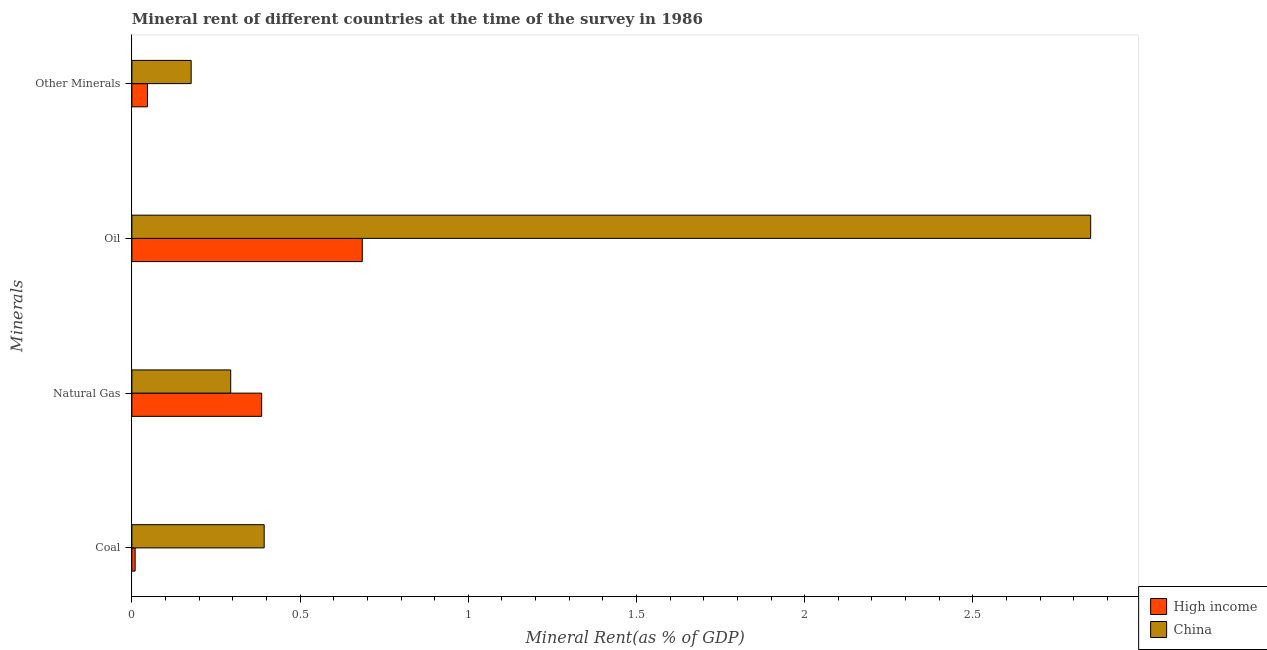Are the number of bars on each tick of the Y-axis equal?
Ensure brevity in your answer.  Yes. How many bars are there on the 2nd tick from the top?
Your answer should be very brief. 2. What is the label of the 4th group of bars from the top?
Your answer should be compact. Coal. What is the oil rent in High income?
Offer a terse response. 0.68. Across all countries, what is the maximum  rent of other minerals?
Your answer should be very brief. 0.18. Across all countries, what is the minimum natural gas rent?
Your response must be concise. 0.29. In which country was the natural gas rent minimum?
Provide a succinct answer. China. What is the total  rent of other minerals in the graph?
Your answer should be very brief. 0.22. What is the difference between the natural gas rent in High income and that in China?
Ensure brevity in your answer.  0.09. What is the difference between the oil rent in High income and the  rent of other minerals in China?
Offer a very short reply. 0.51. What is the average natural gas rent per country?
Your response must be concise. 0.34. What is the difference between the  rent of other minerals and oil rent in China?
Make the answer very short. -2.67. In how many countries, is the oil rent greater than 0.2 %?
Provide a succinct answer. 2. What is the ratio of the oil rent in China to that in High income?
Provide a succinct answer. 4.16. What is the difference between the highest and the second highest  rent of other minerals?
Offer a terse response. 0.13. What is the difference between the highest and the lowest  rent of other minerals?
Your response must be concise. 0.13. Is it the case that in every country, the sum of the natural gas rent and  rent of other minerals is greater than the sum of oil rent and coal rent?
Keep it short and to the point. Yes. How many bars are there?
Offer a terse response. 8. Does the graph contain any zero values?
Provide a succinct answer. No. Where does the legend appear in the graph?
Offer a very short reply. Bottom right. How are the legend labels stacked?
Ensure brevity in your answer.  Vertical. What is the title of the graph?
Give a very brief answer. Mineral rent of different countries at the time of the survey in 1986. Does "Marshall Islands" appear as one of the legend labels in the graph?
Give a very brief answer. No. What is the label or title of the X-axis?
Provide a succinct answer. Mineral Rent(as % of GDP). What is the label or title of the Y-axis?
Your answer should be very brief. Minerals. What is the Mineral Rent(as % of GDP) in High income in Coal?
Keep it short and to the point. 0.01. What is the Mineral Rent(as % of GDP) of China in Coal?
Your answer should be compact. 0.39. What is the Mineral Rent(as % of GDP) in High income in Natural Gas?
Ensure brevity in your answer.  0.39. What is the Mineral Rent(as % of GDP) in China in Natural Gas?
Your answer should be very brief. 0.29. What is the Mineral Rent(as % of GDP) of High income in Oil?
Keep it short and to the point. 0.68. What is the Mineral Rent(as % of GDP) in China in Oil?
Provide a succinct answer. 2.85. What is the Mineral Rent(as % of GDP) in High income in Other Minerals?
Give a very brief answer. 0.05. What is the Mineral Rent(as % of GDP) of China in Other Minerals?
Your response must be concise. 0.18. Across all Minerals, what is the maximum Mineral Rent(as % of GDP) of High income?
Give a very brief answer. 0.68. Across all Minerals, what is the maximum Mineral Rent(as % of GDP) of China?
Your answer should be very brief. 2.85. Across all Minerals, what is the minimum Mineral Rent(as % of GDP) of High income?
Your answer should be compact. 0.01. Across all Minerals, what is the minimum Mineral Rent(as % of GDP) in China?
Offer a terse response. 0.18. What is the total Mineral Rent(as % of GDP) in High income in the graph?
Offer a very short reply. 1.13. What is the total Mineral Rent(as % of GDP) of China in the graph?
Offer a terse response. 3.71. What is the difference between the Mineral Rent(as % of GDP) in High income in Coal and that in Natural Gas?
Provide a succinct answer. -0.38. What is the difference between the Mineral Rent(as % of GDP) in China in Coal and that in Natural Gas?
Keep it short and to the point. 0.1. What is the difference between the Mineral Rent(as % of GDP) in High income in Coal and that in Oil?
Your answer should be very brief. -0.68. What is the difference between the Mineral Rent(as % of GDP) in China in Coal and that in Oil?
Offer a very short reply. -2.46. What is the difference between the Mineral Rent(as % of GDP) in High income in Coal and that in Other Minerals?
Offer a very short reply. -0.04. What is the difference between the Mineral Rent(as % of GDP) in China in Coal and that in Other Minerals?
Provide a short and direct response. 0.22. What is the difference between the Mineral Rent(as % of GDP) of High income in Natural Gas and that in Oil?
Make the answer very short. -0.3. What is the difference between the Mineral Rent(as % of GDP) of China in Natural Gas and that in Oil?
Offer a very short reply. -2.56. What is the difference between the Mineral Rent(as % of GDP) of High income in Natural Gas and that in Other Minerals?
Your response must be concise. 0.34. What is the difference between the Mineral Rent(as % of GDP) of China in Natural Gas and that in Other Minerals?
Offer a terse response. 0.12. What is the difference between the Mineral Rent(as % of GDP) of High income in Oil and that in Other Minerals?
Offer a terse response. 0.64. What is the difference between the Mineral Rent(as % of GDP) of China in Oil and that in Other Minerals?
Keep it short and to the point. 2.67. What is the difference between the Mineral Rent(as % of GDP) in High income in Coal and the Mineral Rent(as % of GDP) in China in Natural Gas?
Ensure brevity in your answer.  -0.28. What is the difference between the Mineral Rent(as % of GDP) in High income in Coal and the Mineral Rent(as % of GDP) in China in Oil?
Keep it short and to the point. -2.84. What is the difference between the Mineral Rent(as % of GDP) of High income in Coal and the Mineral Rent(as % of GDP) of China in Other Minerals?
Keep it short and to the point. -0.17. What is the difference between the Mineral Rent(as % of GDP) in High income in Natural Gas and the Mineral Rent(as % of GDP) in China in Oil?
Keep it short and to the point. -2.46. What is the difference between the Mineral Rent(as % of GDP) of High income in Natural Gas and the Mineral Rent(as % of GDP) of China in Other Minerals?
Your answer should be compact. 0.21. What is the difference between the Mineral Rent(as % of GDP) of High income in Oil and the Mineral Rent(as % of GDP) of China in Other Minerals?
Ensure brevity in your answer.  0.51. What is the average Mineral Rent(as % of GDP) in High income per Minerals?
Offer a very short reply. 0.28. What is the average Mineral Rent(as % of GDP) in China per Minerals?
Offer a very short reply. 0.93. What is the difference between the Mineral Rent(as % of GDP) in High income and Mineral Rent(as % of GDP) in China in Coal?
Provide a succinct answer. -0.38. What is the difference between the Mineral Rent(as % of GDP) of High income and Mineral Rent(as % of GDP) of China in Natural Gas?
Give a very brief answer. 0.09. What is the difference between the Mineral Rent(as % of GDP) of High income and Mineral Rent(as % of GDP) of China in Oil?
Provide a short and direct response. -2.17. What is the difference between the Mineral Rent(as % of GDP) of High income and Mineral Rent(as % of GDP) of China in Other Minerals?
Your answer should be compact. -0.13. What is the ratio of the Mineral Rent(as % of GDP) of High income in Coal to that in Natural Gas?
Offer a terse response. 0.03. What is the ratio of the Mineral Rent(as % of GDP) in China in Coal to that in Natural Gas?
Your answer should be compact. 1.34. What is the ratio of the Mineral Rent(as % of GDP) of High income in Coal to that in Oil?
Provide a short and direct response. 0.01. What is the ratio of the Mineral Rent(as % of GDP) of China in Coal to that in Oil?
Offer a terse response. 0.14. What is the ratio of the Mineral Rent(as % of GDP) of High income in Coal to that in Other Minerals?
Provide a short and direct response. 0.21. What is the ratio of the Mineral Rent(as % of GDP) in China in Coal to that in Other Minerals?
Keep it short and to the point. 2.23. What is the ratio of the Mineral Rent(as % of GDP) of High income in Natural Gas to that in Oil?
Your answer should be compact. 0.56. What is the ratio of the Mineral Rent(as % of GDP) in China in Natural Gas to that in Oil?
Your answer should be very brief. 0.1. What is the ratio of the Mineral Rent(as % of GDP) of High income in Natural Gas to that in Other Minerals?
Provide a succinct answer. 8.33. What is the ratio of the Mineral Rent(as % of GDP) of China in Natural Gas to that in Other Minerals?
Your answer should be very brief. 1.67. What is the ratio of the Mineral Rent(as % of GDP) of High income in Oil to that in Other Minerals?
Keep it short and to the point. 14.79. What is the ratio of the Mineral Rent(as % of GDP) in China in Oil to that in Other Minerals?
Ensure brevity in your answer.  16.17. What is the difference between the highest and the second highest Mineral Rent(as % of GDP) of High income?
Ensure brevity in your answer.  0.3. What is the difference between the highest and the second highest Mineral Rent(as % of GDP) in China?
Give a very brief answer. 2.46. What is the difference between the highest and the lowest Mineral Rent(as % of GDP) of High income?
Your answer should be very brief. 0.68. What is the difference between the highest and the lowest Mineral Rent(as % of GDP) in China?
Offer a very short reply. 2.67. 